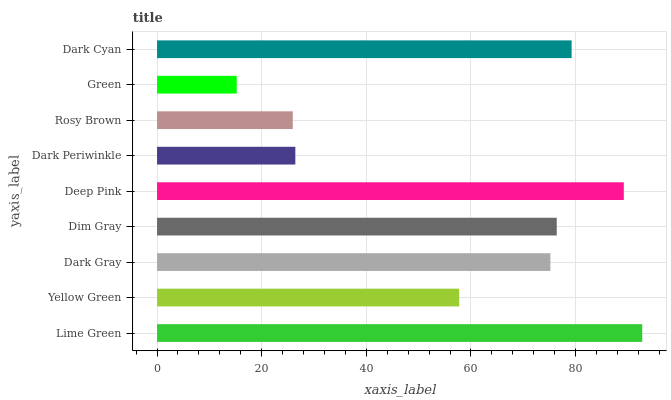Is Green the minimum?
Answer yes or no. Yes. Is Lime Green the maximum?
Answer yes or no. Yes. Is Yellow Green the minimum?
Answer yes or no. No. Is Yellow Green the maximum?
Answer yes or no. No. Is Lime Green greater than Yellow Green?
Answer yes or no. Yes. Is Yellow Green less than Lime Green?
Answer yes or no. Yes. Is Yellow Green greater than Lime Green?
Answer yes or no. No. Is Lime Green less than Yellow Green?
Answer yes or no. No. Is Dark Gray the high median?
Answer yes or no. Yes. Is Dark Gray the low median?
Answer yes or no. Yes. Is Rosy Brown the high median?
Answer yes or no. No. Is Dark Periwinkle the low median?
Answer yes or no. No. 